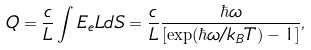<formula> <loc_0><loc_0><loc_500><loc_500>Q = \frac { c } { L } \int E _ { e } L d S = \frac { c } { L } \frac { \hbar { \omega } } { [ \exp ( \hbar { \omega } / k _ { B } T ) - 1 ] } ,</formula> 